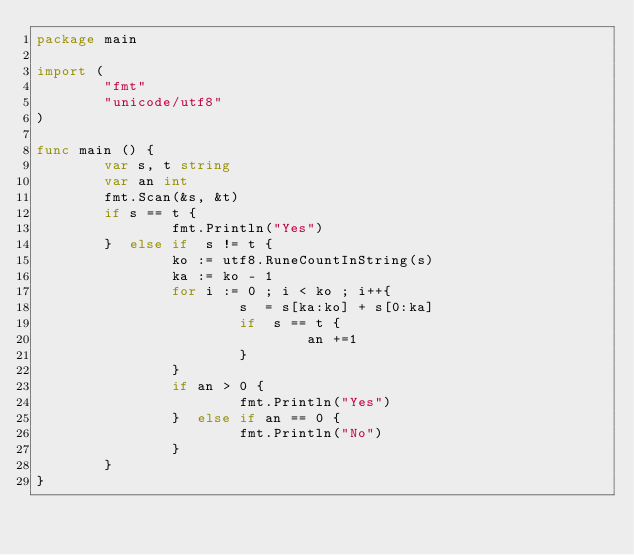<code> <loc_0><loc_0><loc_500><loc_500><_Go_>package main 

import (
        "fmt"
        "unicode/utf8"
)

func main () {
        var s, t string
        var an int
        fmt.Scan(&s, &t)
        if s == t {
                fmt.Println("Yes")
        }  else if  s != t {
                ko := utf8.RuneCountInString(s)
                ka := ko - 1
                for i := 0 ; i < ko ; i++{
                        s  = s[ka:ko] + s[0:ka]
                        if  s == t {
                                an +=1
                        }
                }
                if an > 0 { 
                        fmt.Println("Yes")
                }  else if an == 0 {
                        fmt.Println("No")
                }
        }
}
</code> 